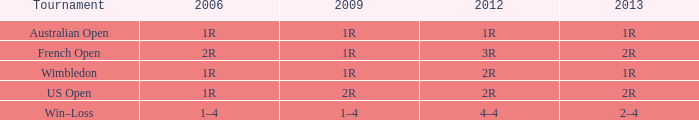When the 2013 is 2r and a tournament was the us open, what can you tell me about the year 2006? 1R. 